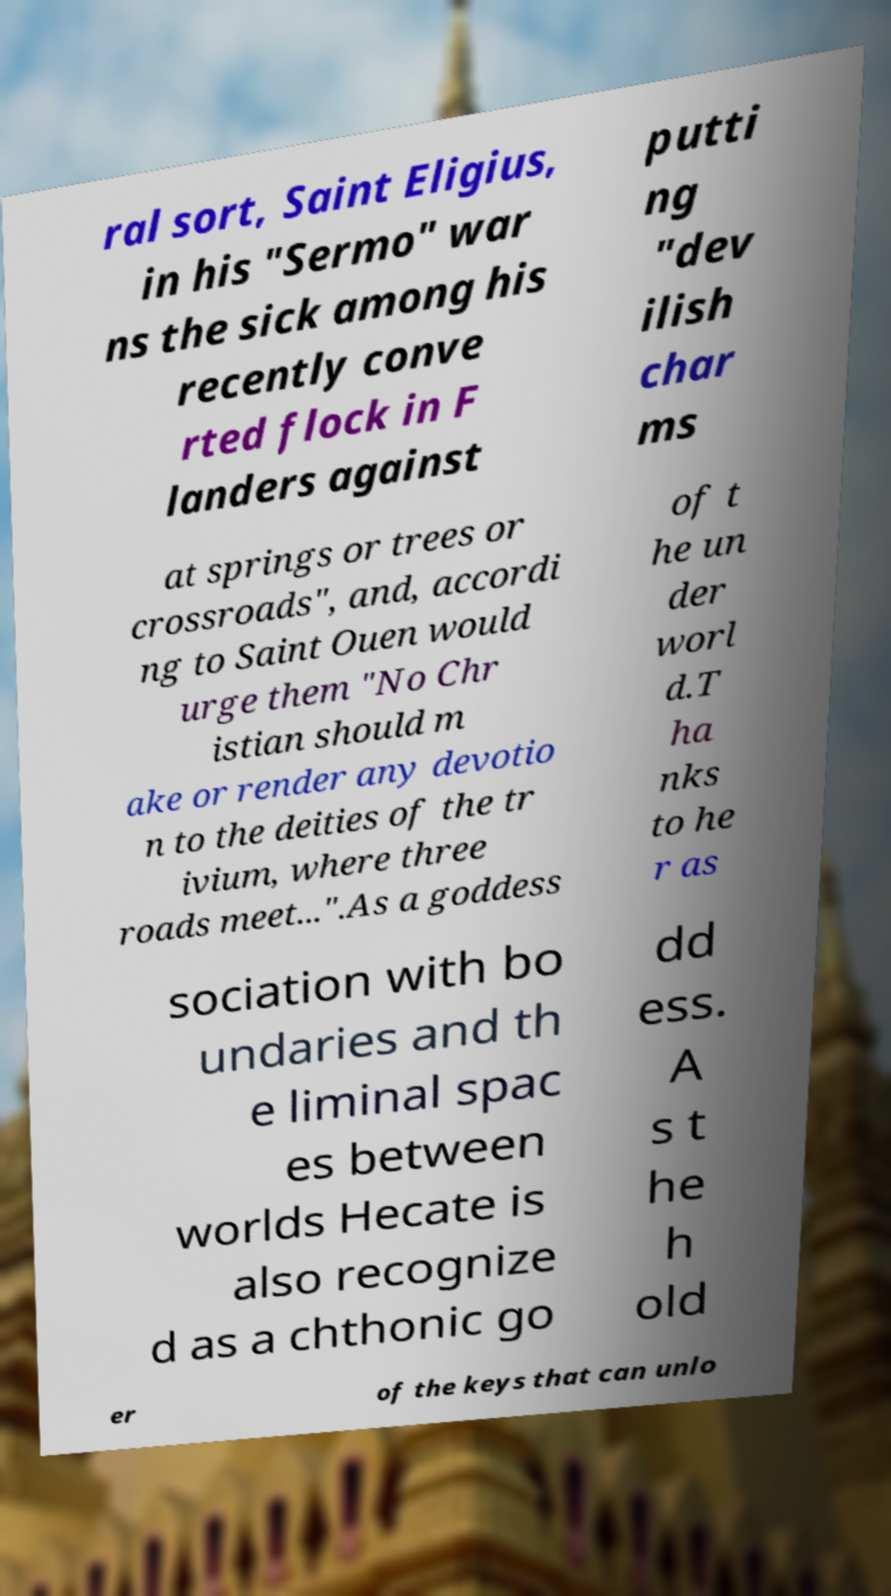There's text embedded in this image that I need extracted. Can you transcribe it verbatim? ral sort, Saint Eligius, in his "Sermo" war ns the sick among his recently conve rted flock in F landers against putti ng "dev ilish char ms at springs or trees or crossroads", and, accordi ng to Saint Ouen would urge them "No Chr istian should m ake or render any devotio n to the deities of the tr ivium, where three roads meet...".As a goddess of t he un der worl d.T ha nks to he r as sociation with bo undaries and th e liminal spac es between worlds Hecate is also recognize d as a chthonic go dd ess. A s t he h old er of the keys that can unlo 